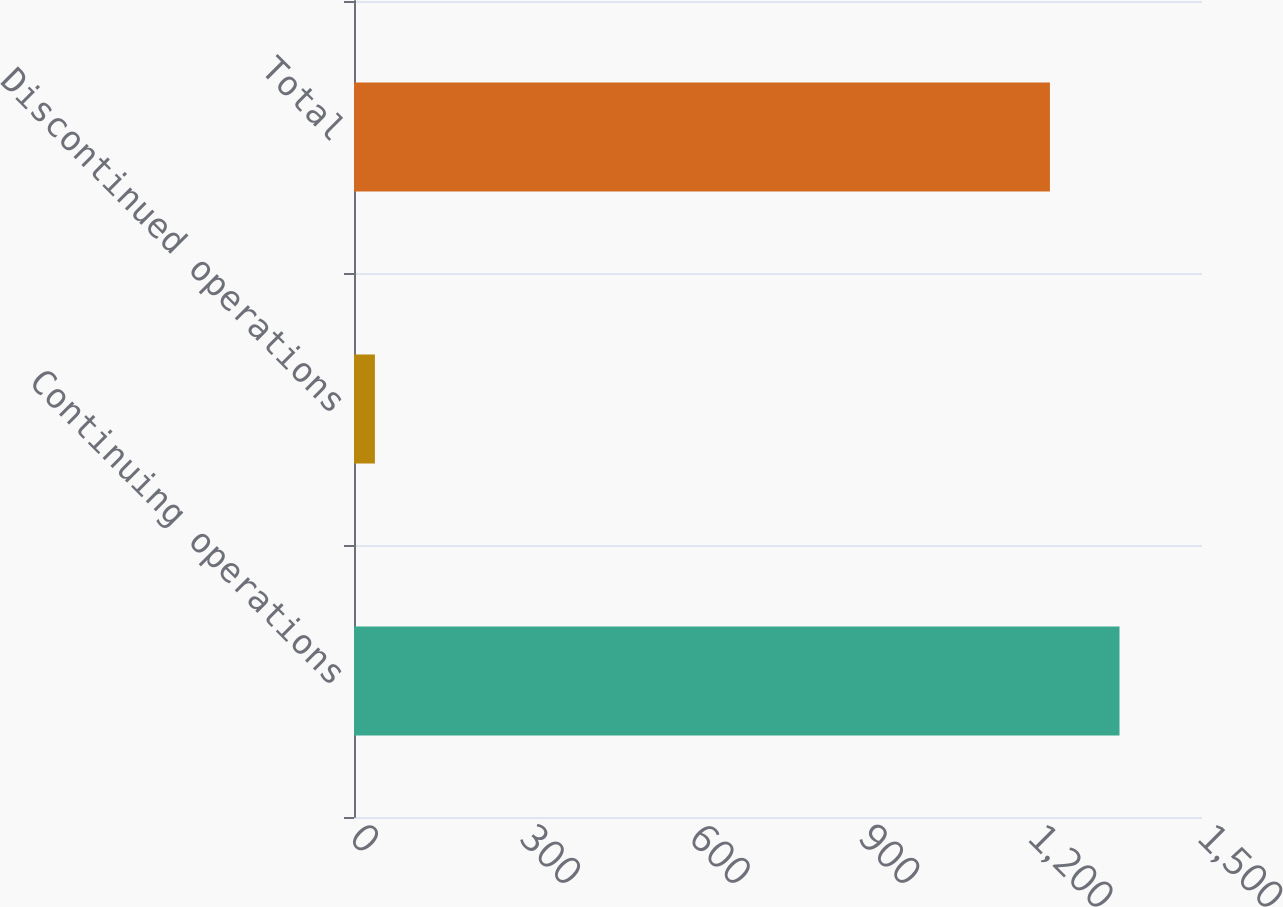<chart> <loc_0><loc_0><loc_500><loc_500><bar_chart><fcel>Continuing operations<fcel>Discontinued operations<fcel>Total<nl><fcel>1354.1<fcel>37<fcel>1231<nl></chart> 